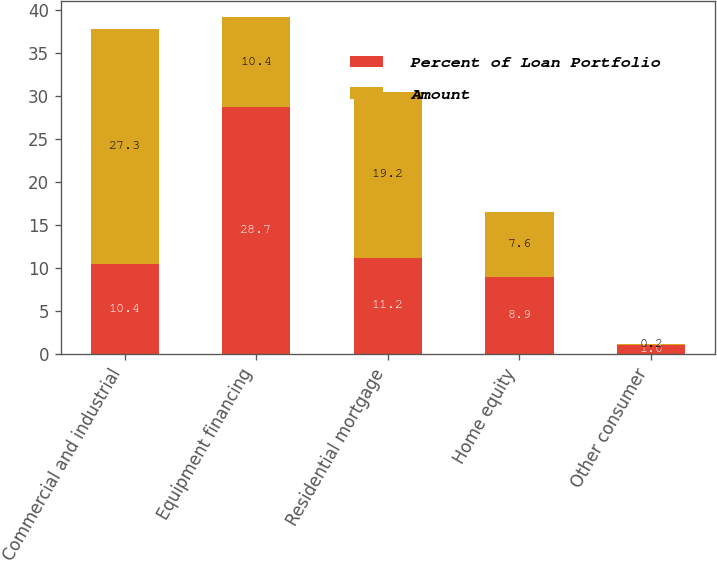<chart> <loc_0><loc_0><loc_500><loc_500><stacked_bar_chart><ecel><fcel>Commercial and industrial<fcel>Equipment financing<fcel>Residential mortgage<fcel>Home equity<fcel>Other consumer<nl><fcel>Percent of Loan Portfolio<fcel>10.4<fcel>28.7<fcel>11.2<fcel>8.9<fcel>1<nl><fcel>Amount<fcel>27.3<fcel>10.4<fcel>19.2<fcel>7.6<fcel>0.2<nl></chart> 